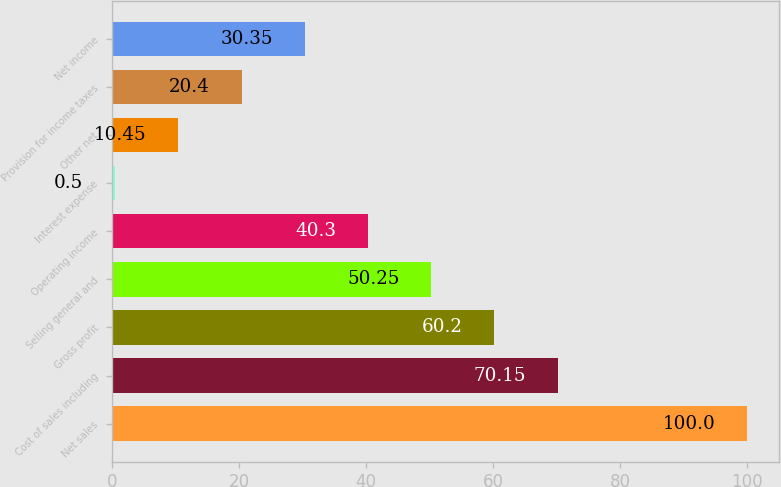Convert chart. <chart><loc_0><loc_0><loc_500><loc_500><bar_chart><fcel>Net sales<fcel>Cost of sales including<fcel>Gross profit<fcel>Selling general and<fcel>Operating income<fcel>Interest expense<fcel>Other net<fcel>Provision for income taxes<fcel>Net income<nl><fcel>100<fcel>70.15<fcel>60.2<fcel>50.25<fcel>40.3<fcel>0.5<fcel>10.45<fcel>20.4<fcel>30.35<nl></chart> 